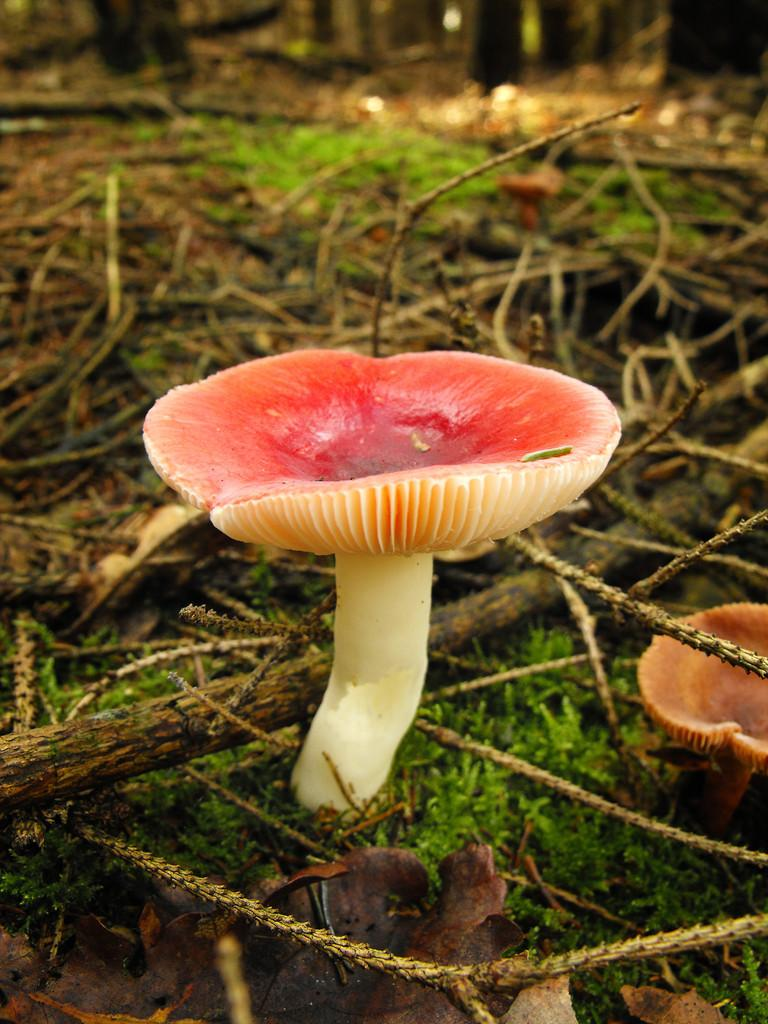What type of vegetation is present in the image? There are mushrooms in the image. What is the ground covered with? The ground is covered with grass. What other objects can be seen in the image? There are wood sticks visible in the image. What color is the baby's shirt in the image? There is no baby or shirt present in the image. 